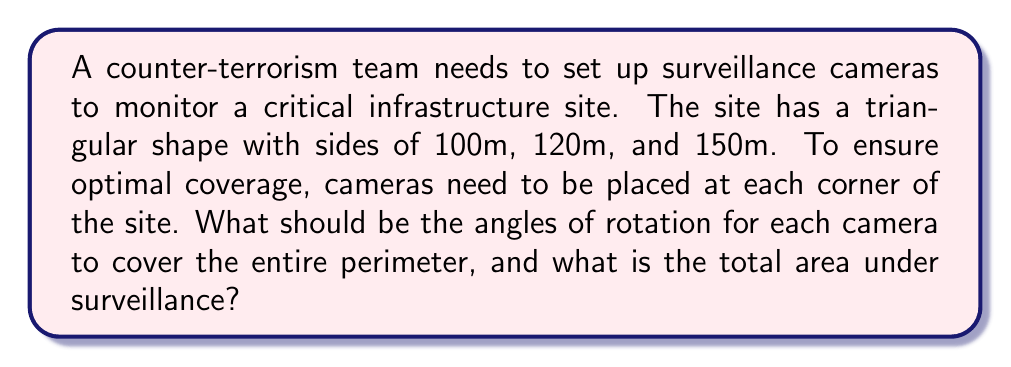Teach me how to tackle this problem. To solve this problem, we'll follow these steps:

1. Determine the angles of the triangular site using the law of cosines.
2. Calculate the rotation angles for each camera.
3. Find the area of the triangular site using Heron's formula.

Step 1: Determine the angles of the triangle

Let's label the sides: a = 100m, b = 120m, c = 150m
We'll use the law of cosines: $c^2 = a^2 + b^2 - 2ab \cos(C)$

For angle A (opposite to side a):
$$\cos(A) = \frac{b^2 + c^2 - a^2}{2bc} = \frac{120^2 + 150^2 - 100^2}{2 \cdot 120 \cdot 150} \approx 0.7200$$
$$A = \arccos(0.7200) \approx 0.7754 \text{ radians} \approx 44.42°$$

For angle B (opposite to side b):
$$\cos(B) = \frac{a^2 + c^2 - b^2}{2ac} = \frac{100^2 + 150^2 - 120^2}{2 \cdot 100 \cdot 150} \approx 0.5333$$
$$B = \arccos(0.5333) \approx 0.9828 \text{ radians} \approx 56.31°$$

For angle C (opposite to side c):
$$C = 180° - A - B \approx 79.27°$$

Step 2: Calculate rotation angles for cameras

Each camera needs to be rotated half of the interior angle at its corner:

Camera at A: $44.42° / 2 = 22.21°$
Camera at B: $56.31° / 2 = 28.16°$
Camera at C: $79.27° / 2 = 39.64°$

Step 3: Calculate the area of the triangle using Heron's formula

First, calculate the semi-perimeter s:
$$s = \frac{a + b + c}{2} = \frac{100 + 120 + 150}{2} = 185\text{m}$$

Then use Heron's formula:
$$\text{Area} = \sqrt{s(s-a)(s-b)(s-c)}$$
$$= \sqrt{185(185-100)(185-120)(185-150)}$$
$$= \sqrt{185 \cdot 85 \cdot 65 \cdot 35}$$
$$\approx 5544.13\text{m}^2$$

[asy]
import geometry;

pair A = (0,0);
pair B = (150,0);
pair C = (48.8,88.2);

draw(A--B--C--A);

label("A", A, SW);
label("B", B, SE);
label("C", C, N);

label("100m", (C--A)/2, NW);
label("120m", (B--C)/2, NE);
label("150m", (A--B)/2, S);

draw(arc(A, 30, 0, 44.42), arrow=Arrow(TeXHead));
draw(arc(B, 30, 180-56.31, 180), arrow=Arrow(TeXHead));
draw(arc(C, 30, 270, 270+79.27), arrow=Arrow(TeXHead));

label("22.21°", A + (20,10), NE);
label("28.16°", B + (-20,10), NW);
label("39.64°", C + (0,-20), S);
[/asy]
Answer: The rotation angles for the cameras should be 22.21° at corner A, 28.16° at corner B, and 39.64° at corner C. The total area under surveillance is approximately 5544.13 square meters. 